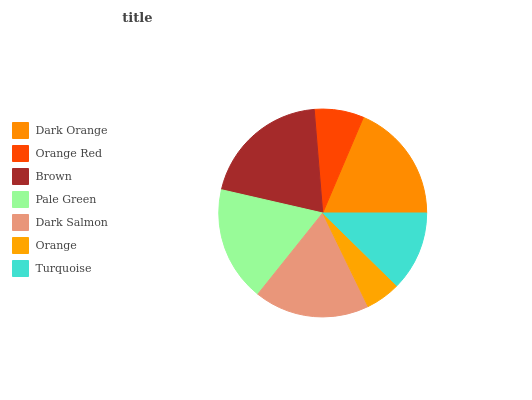Is Orange the minimum?
Answer yes or no. Yes. Is Brown the maximum?
Answer yes or no. Yes. Is Orange Red the minimum?
Answer yes or no. No. Is Orange Red the maximum?
Answer yes or no. No. Is Dark Orange greater than Orange Red?
Answer yes or no. Yes. Is Orange Red less than Dark Orange?
Answer yes or no. Yes. Is Orange Red greater than Dark Orange?
Answer yes or no. No. Is Dark Orange less than Orange Red?
Answer yes or no. No. Is Pale Green the high median?
Answer yes or no. Yes. Is Pale Green the low median?
Answer yes or no. Yes. Is Brown the high median?
Answer yes or no. No. Is Orange Red the low median?
Answer yes or no. No. 